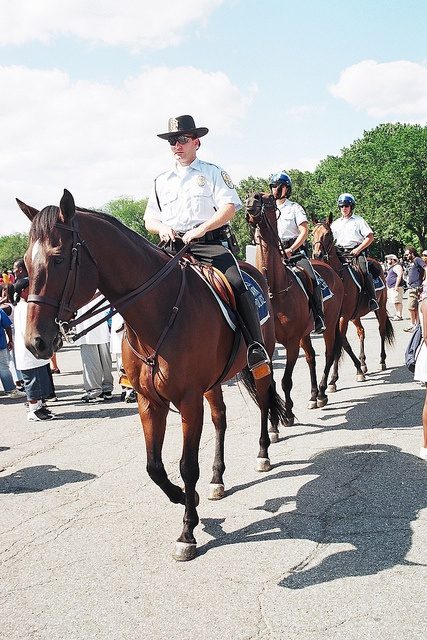Describe the objects in this image and their specific colors. I can see horse in white, black, maroon, lightgray, and gray tones, people in white, black, gray, and darkgray tones, horse in white, black, maroon, gray, and lightgray tones, horse in white, black, maroon, lightgray, and gray tones, and people in white, black, gray, and darkgray tones in this image. 